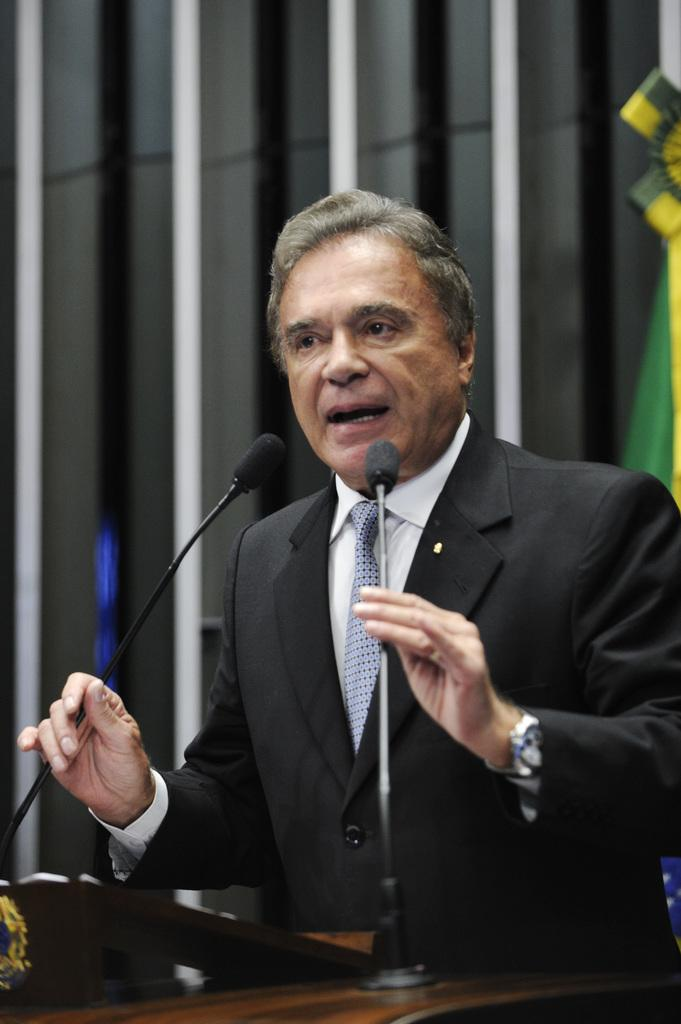Who is the main subject in the image? There is a man in the image. What is the man doing in the image? The man is talking on a microphone. What is the man wearing in the image? The man is wearing a black suit. What other object can be seen in the image? There is a table in the image. What type of receipt can be seen in the man's hand in the image? There is no receipt present in the image; the man is holding a microphone. 